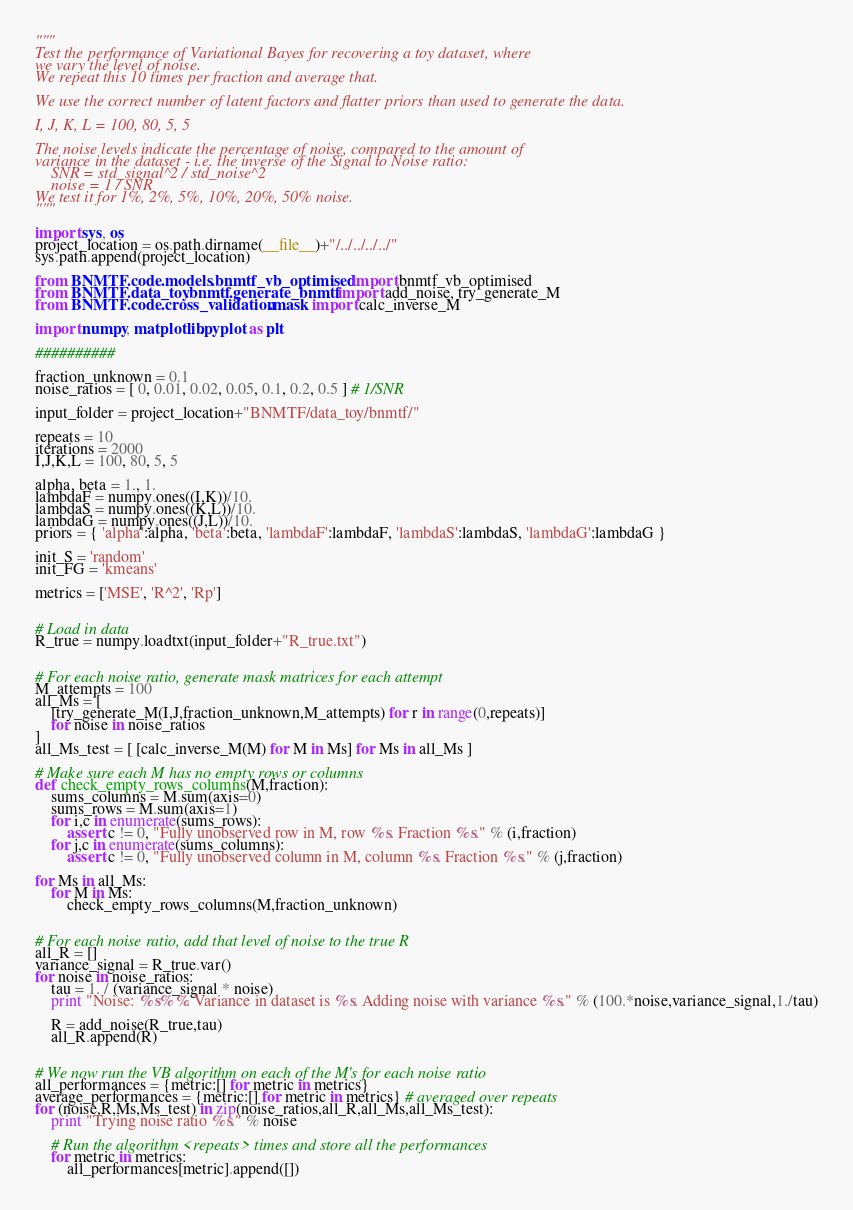Convert code to text. <code><loc_0><loc_0><loc_500><loc_500><_Python_>"""
Test the performance of Variational Bayes for recovering a toy dataset, where 
we vary the level of noise.
We repeat this 10 times per fraction and average that.

We use the correct number of latent factors and flatter priors than used to generate the data.

I, J, K, L = 100, 80, 5, 5

The noise levels indicate the percentage of noise, compared to the amount of 
variance in the dataset - i.e. the inverse of the Signal to Noise ratio:
    SNR = std_signal^2 / std_noise^2
    noise = 1 / SNR
We test it for 1%, 2%, 5%, 10%, 20%, 50% noise.
"""

import sys, os
project_location = os.path.dirname(__file__)+"/../../../../"
sys.path.append(project_location)

from BNMTF.code.models.bnmtf_vb_optimised import bnmtf_vb_optimised
from BNMTF.data_toy.bnmtf.generate_bnmtf import add_noise, try_generate_M
from BNMTF.code.cross_validation.mask import calc_inverse_M

import numpy, matplotlib.pyplot as plt

##########

fraction_unknown = 0.1
noise_ratios = [ 0, 0.01, 0.02, 0.05, 0.1, 0.2, 0.5 ] # 1/SNR

input_folder = project_location+"BNMTF/data_toy/bnmtf/"

repeats = 10
iterations = 2000
I,J,K,L = 100, 80, 5, 5

alpha, beta = 1., 1.
lambdaF = numpy.ones((I,K))/10.
lambdaS = numpy.ones((K,L))/10.
lambdaG = numpy.ones((J,L))/10.
priors = { 'alpha':alpha, 'beta':beta, 'lambdaF':lambdaF, 'lambdaS':lambdaS, 'lambdaG':lambdaG }

init_S = 'random'
init_FG = 'kmeans'

metrics = ['MSE', 'R^2', 'Rp']


# Load in data
R_true = numpy.loadtxt(input_folder+"R_true.txt")


# For each noise ratio, generate mask matrices for each attempt
M_attempts = 100
all_Ms = [ 
    [try_generate_M(I,J,fraction_unknown,M_attempts) for r in range(0,repeats)]
    for noise in noise_ratios
]
all_Ms_test = [ [calc_inverse_M(M) for M in Ms] for Ms in all_Ms ]

# Make sure each M has no empty rows or columns
def check_empty_rows_columns(M,fraction):
    sums_columns = M.sum(axis=0)
    sums_rows = M.sum(axis=1)
    for i,c in enumerate(sums_rows):
        assert c != 0, "Fully unobserved row in M, row %s. Fraction %s." % (i,fraction)
    for j,c in enumerate(sums_columns):
        assert c != 0, "Fully unobserved column in M, column %s. Fraction %s." % (j,fraction)
        
for Ms in all_Ms:
    for M in Ms:
        check_empty_rows_columns(M,fraction_unknown)


# For each noise ratio, add that level of noise to the true R
all_R = []
variance_signal = R_true.var()
for noise in noise_ratios:
    tau = 1. / (variance_signal * noise)
    print "Noise: %s%%. Variance in dataset is %s. Adding noise with variance %s." % (100.*noise,variance_signal,1./tau)
    
    R = add_noise(R_true,tau)
    all_R.append(R)
    
    
# We now run the VB algorithm on each of the M's for each noise ratio    
all_performances = {metric:[] for metric in metrics} 
average_performances = {metric:[] for metric in metrics} # averaged over repeats
for (noise,R,Ms,Ms_test) in zip(noise_ratios,all_R,all_Ms,all_Ms_test):
    print "Trying noise ratio %s." % noise
    
    # Run the algorithm <repeats> times and store all the performances
    for metric in metrics:
        all_performances[metric].append([])</code> 